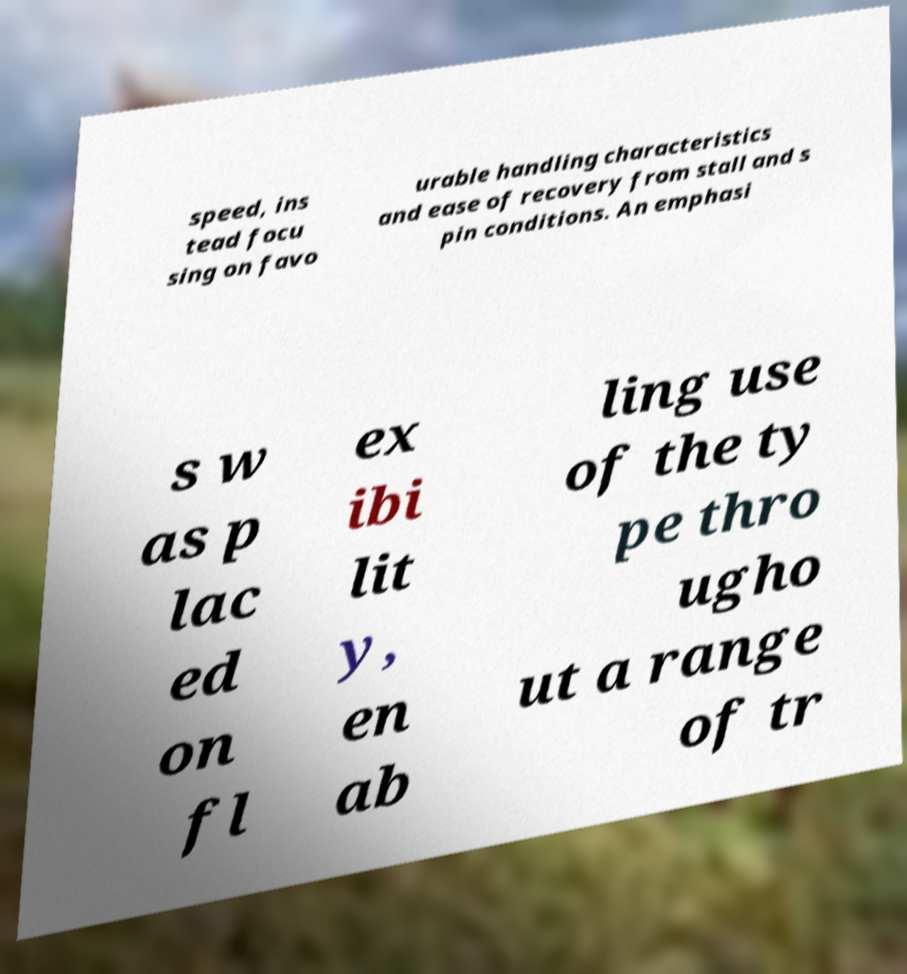Please identify and transcribe the text found in this image. speed, ins tead focu sing on favo urable handling characteristics and ease of recovery from stall and s pin conditions. An emphasi s w as p lac ed on fl ex ibi lit y, en ab ling use of the ty pe thro ugho ut a range of tr 